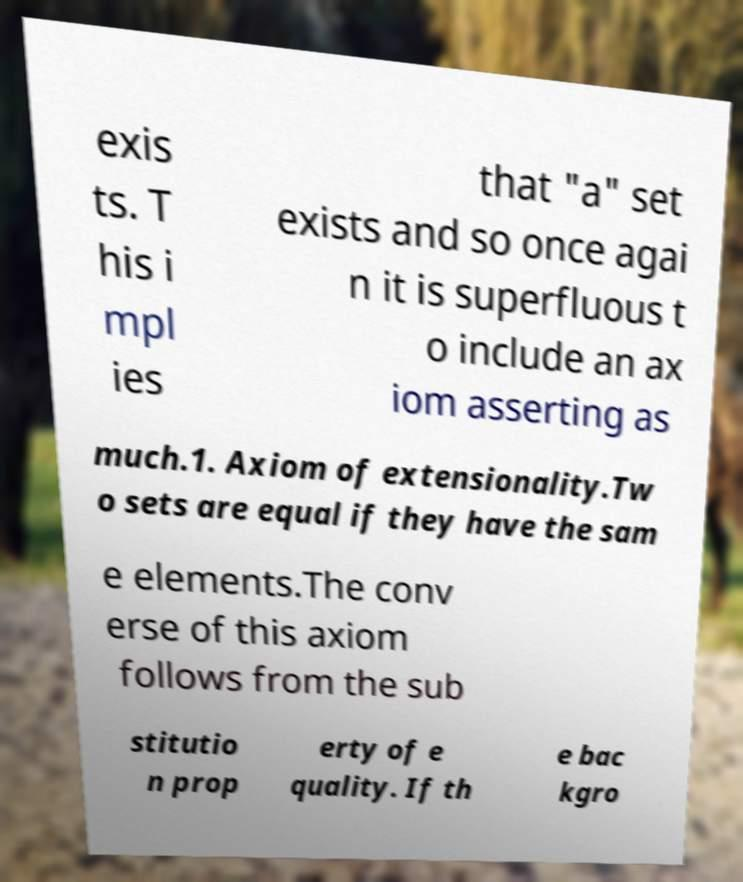Please identify and transcribe the text found in this image. exis ts. T his i mpl ies that "a" set exists and so once agai n it is superfluous t o include an ax iom asserting as much.1. Axiom of extensionality.Tw o sets are equal if they have the sam e elements.The conv erse of this axiom follows from the sub stitutio n prop erty of e quality. If th e bac kgro 